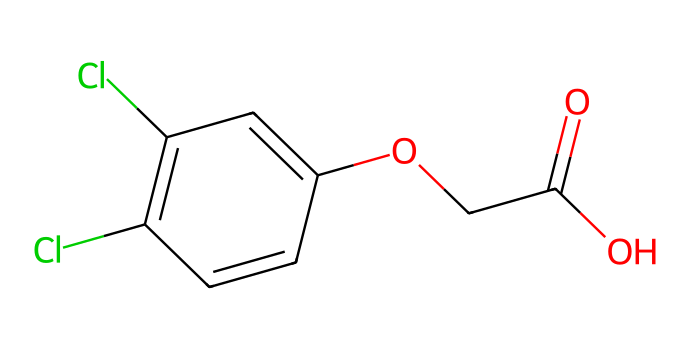What is the molecular formula of 2,4-D? The molecular formula can be derived from the SMILES representation by counting the types and numbers of each atom present in the structure. In the SMILES string, we can identify 8 carbon (C) atoms, 7 hydrogen (H) atoms, 2 chlorine (Cl) atoms, and 4 oxygen (O) atoms. Hence, the molecular formula is C8H6Cl2O3.
Answer: C8H6Cl2O3 How many rings are present in the structure of 2,4-D? By analyzing the SMILES representation, we can observe the notation 'C1=...' indicating the start of a ring, and the closing 'C=C1' showing the completion of that ring. There is one ring structure formed by the arrangement of carbon atoms.
Answer: 1 What functional groups are present in 2,4-D? The SMILES representation contains a carboxylic acid group (shown as 'C(=O)O') and an ether linkage (indicated by the 'O' linked to 'C'). These groups can be visibly identified in the molecular structure, allowing us to determine the presence of these functional groups.
Answer: carboxylic acid, ether What elements constitute the herbicide 2,4-D? By examining the molecular formula derived from the structure, we can identify the elements: carbon (C), hydrogen (H), chlorine (Cl), and oxygen (O). These elements are found in the structure, confirming their presence in the herbicide.
Answer: carbon, hydrogen, chlorine, oxygen What is the total number of chlorine atoms in 2,4-D? The chemical structure features two chlorine (Cl) atoms, which can be recognized within the SMILES representation as two instances of 'Cl'. Therefore, we can confirm the count of chlorine atoms in the molecule.
Answer: 2 How does the structure of 2,4-D contribute to its selectivity as a herbicide? The selective nature of 2,4-D can be attributed to its specific molecular structure, which mimics natural plant hormones (auxins). This structure, primarily due to the presence of the aromatic ring and the attached functional groups, affects plant growth regulation without harming certain crops.
Answer: mimics plant hormones 